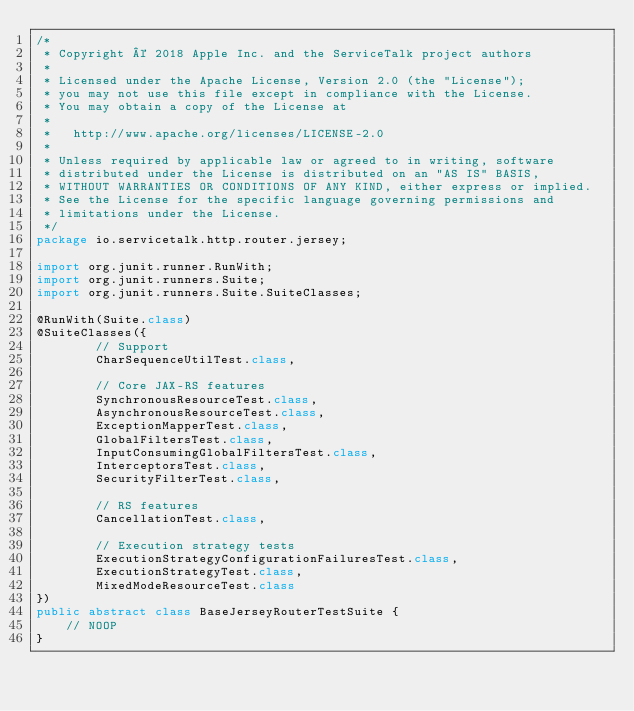Convert code to text. <code><loc_0><loc_0><loc_500><loc_500><_Java_>/*
 * Copyright © 2018 Apple Inc. and the ServiceTalk project authors
 *
 * Licensed under the Apache License, Version 2.0 (the "License");
 * you may not use this file except in compliance with the License.
 * You may obtain a copy of the License at
 *
 *   http://www.apache.org/licenses/LICENSE-2.0
 *
 * Unless required by applicable law or agreed to in writing, software
 * distributed under the License is distributed on an "AS IS" BASIS,
 * WITHOUT WARRANTIES OR CONDITIONS OF ANY KIND, either express or implied.
 * See the License for the specific language governing permissions and
 * limitations under the License.
 */
package io.servicetalk.http.router.jersey;

import org.junit.runner.RunWith;
import org.junit.runners.Suite;
import org.junit.runners.Suite.SuiteClasses;

@RunWith(Suite.class)
@SuiteClasses({
        // Support
        CharSequenceUtilTest.class,

        // Core JAX-RS features
        SynchronousResourceTest.class,
        AsynchronousResourceTest.class,
        ExceptionMapperTest.class,
        GlobalFiltersTest.class,
        InputConsumingGlobalFiltersTest.class,
        InterceptorsTest.class,
        SecurityFilterTest.class,

        // RS features
        CancellationTest.class,

        // Execution strategy tests
        ExecutionStrategyConfigurationFailuresTest.class,
        ExecutionStrategyTest.class,
        MixedModeResourceTest.class
})
public abstract class BaseJerseyRouterTestSuite {
    // NOOP
}
</code> 